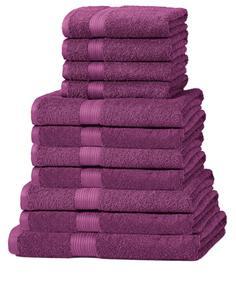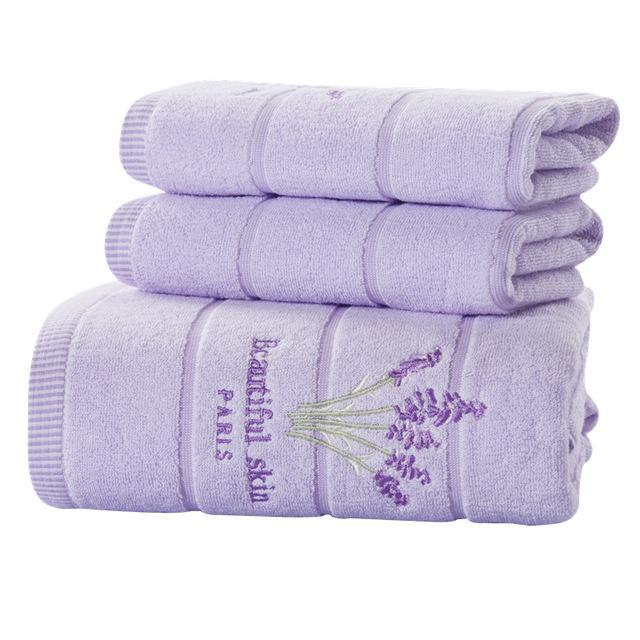The first image is the image on the left, the second image is the image on the right. Assess this claim about the two images: "There are two stacks of towels and they are not both the exact same color.". Correct or not? Answer yes or no. Yes. The first image is the image on the left, the second image is the image on the right. Analyze the images presented: Is the assertion "There are exactly three towels in the right image." valid? Answer yes or no. Yes. 